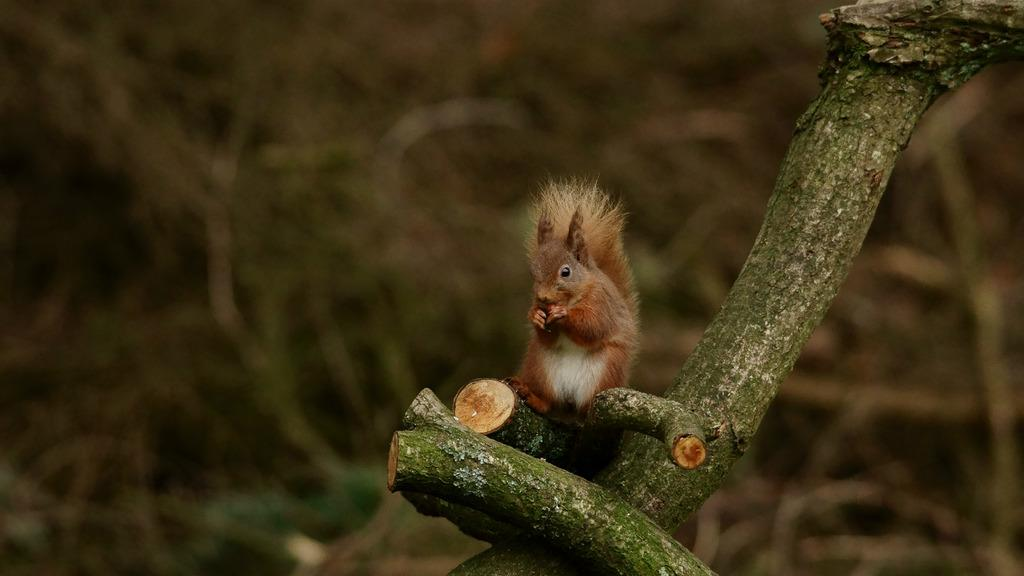What type of animal is in the image? There is a squirrel in the image. Where is the squirrel located in the image? The squirrel is sitting on the branch of a tree. What type of juice is the squirrel drinking in the image? There is no juice present in the image; it features a squirrel sitting on a tree branch. How many turkeys can be seen in the image? There are no turkeys present in the image; it features a squirrel sitting on a tree branch. 